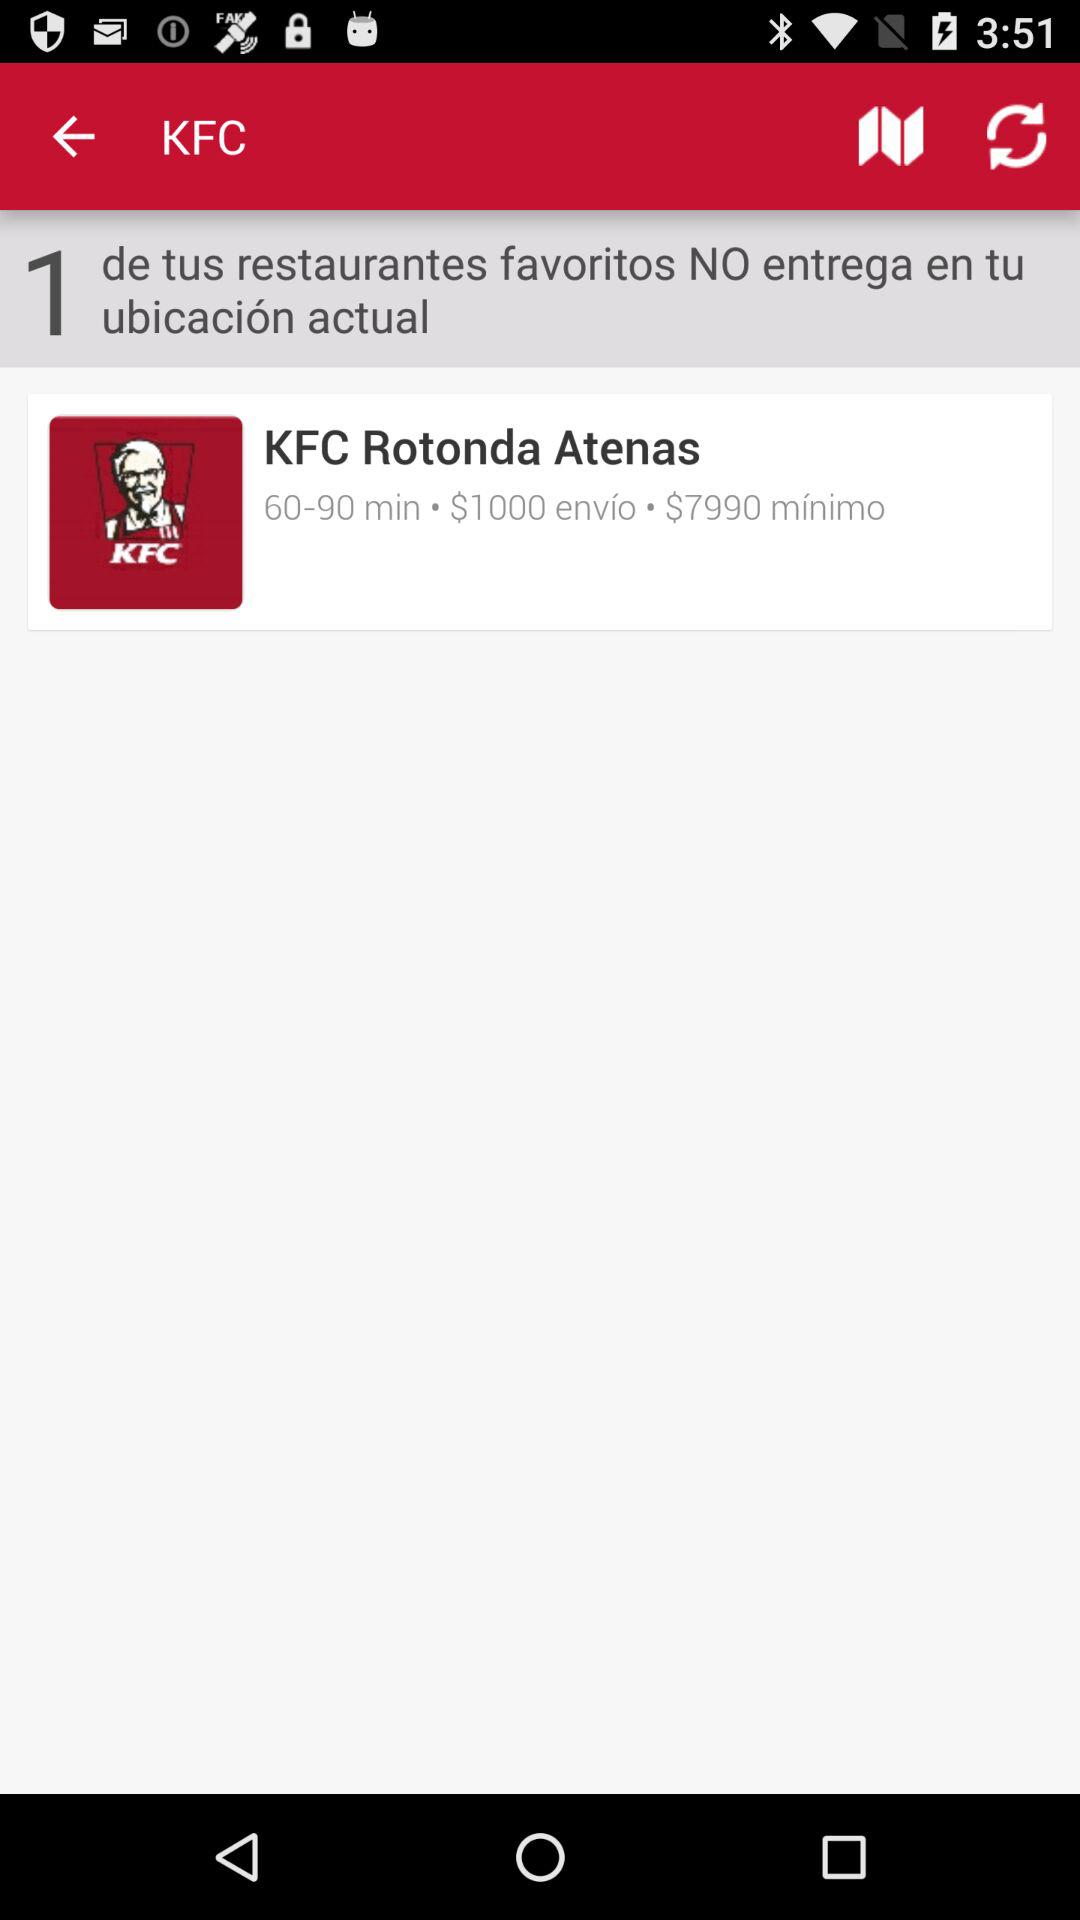How many minutes is the estimated delivery time for KFC Rotonda Atenas?
Answer the question using a single word or phrase. 60-90 min 